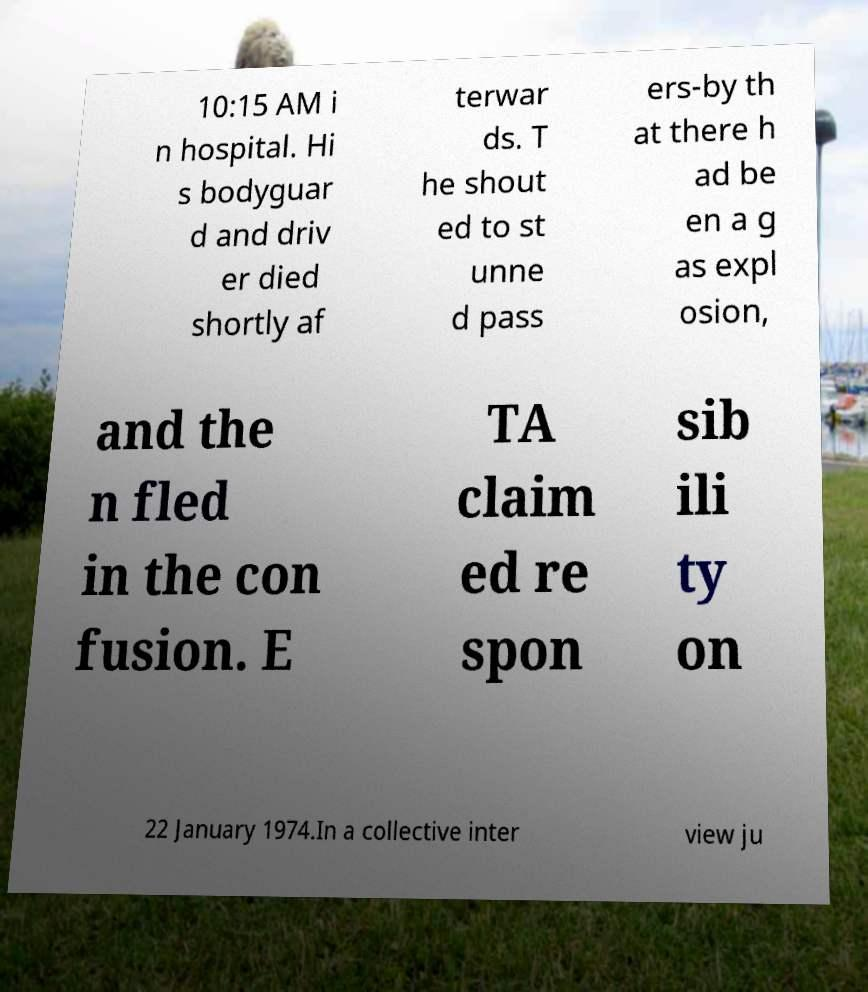Can you accurately transcribe the text from the provided image for me? 10:15 AM i n hospital. Hi s bodyguar d and driv er died shortly af terwar ds. T he shout ed to st unne d pass ers-by th at there h ad be en a g as expl osion, and the n fled in the con fusion. E TA claim ed re spon sib ili ty on 22 January 1974.In a collective inter view ju 